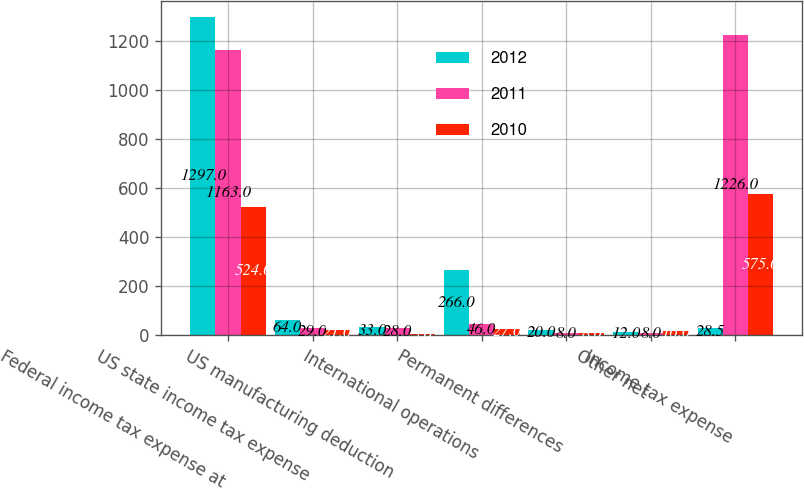Convert chart. <chart><loc_0><loc_0><loc_500><loc_500><stacked_bar_chart><ecel><fcel>Federal income tax expense at<fcel>US state income tax expense<fcel>US manufacturing deduction<fcel>International operations<fcel>Permanent differences<fcel>Other net<fcel>Income tax expense<nl><fcel>2012<fcel>1297<fcel>64<fcel>33<fcel>266<fcel>20<fcel>12<fcel>28.5<nl><fcel>2011<fcel>1163<fcel>29<fcel>28<fcel>46<fcel>8<fcel>8<fcel>1226<nl><fcel>2010<fcel>524<fcel>21<fcel>5<fcel>27<fcel>8<fcel>16<fcel>575<nl></chart> 